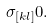<formula> <loc_0><loc_0><loc_500><loc_500>\sigma _ { [ k l ] } 0 .</formula> 